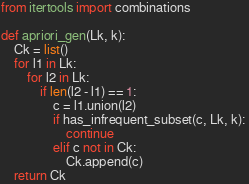<code> <loc_0><loc_0><loc_500><loc_500><_Python_>from itertools import combinations

def apriori_gen(Lk, k):
    Ck = list()
    for l1 in Lk:
        for l2 in Lk:
            if len(l2 - l1) == 1:
                c = l1.union(l2)
                if has_infrequent_subset(c, Lk, k): 
                    continue
                elif c not in Ck:
                    Ck.append(c)
    return Ck
</code> 